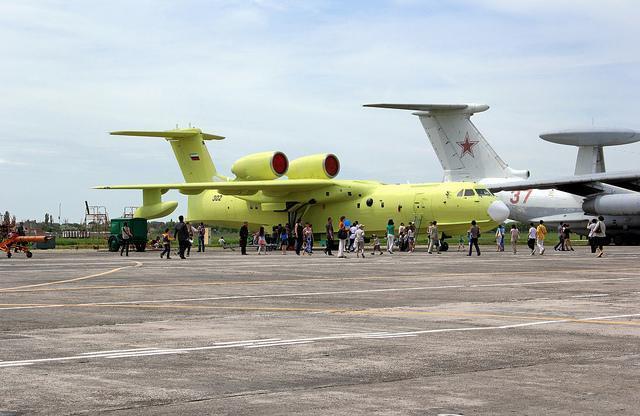How many planes are visible?
Give a very brief answer. 2. How many airplanes can be seen?
Give a very brief answer. 2. 